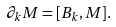<formula> <loc_0><loc_0><loc_500><loc_500>\partial _ { k } M = [ B _ { k } , M ] .</formula> 